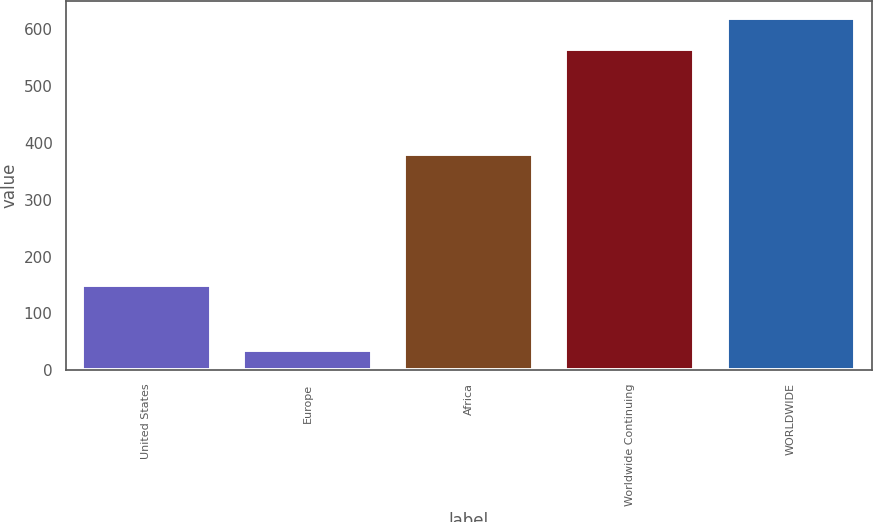Convert chart to OTSL. <chart><loc_0><loc_0><loc_500><loc_500><bar_chart><fcel>United States<fcel>Europe<fcel>Africa<fcel>Worldwide Continuing<fcel>WORLDWIDE<nl><fcel>150<fcel>35<fcel>381<fcel>566<fcel>619.1<nl></chart> 